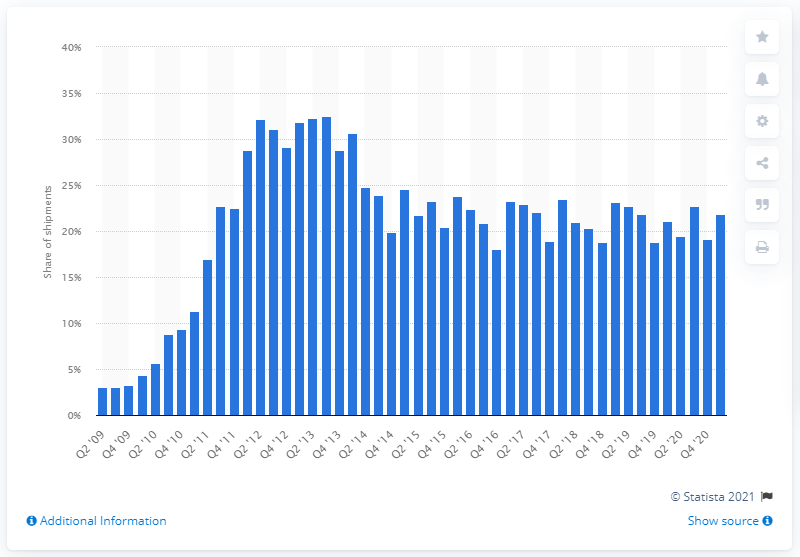List a handful of essential elements in this visual. According to data from the first quarter of 2021, Samsung's market share was 21.8%. 